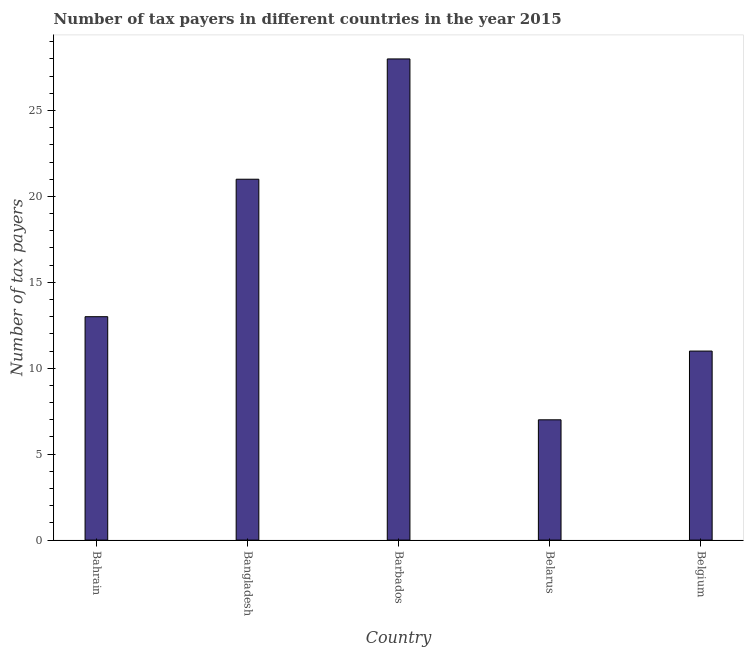Does the graph contain any zero values?
Your response must be concise. No. What is the title of the graph?
Your answer should be compact. Number of tax payers in different countries in the year 2015. What is the label or title of the Y-axis?
Your response must be concise. Number of tax payers. Across all countries, what is the minimum number of tax payers?
Provide a succinct answer. 7. In which country was the number of tax payers maximum?
Your answer should be very brief. Barbados. In which country was the number of tax payers minimum?
Give a very brief answer. Belarus. What is the median number of tax payers?
Your answer should be compact. 13. In how many countries, is the number of tax payers greater than 21 ?
Give a very brief answer. 1. What is the ratio of the number of tax payers in Bangladesh to that in Belgium?
Ensure brevity in your answer.  1.91. Is the number of tax payers in Bangladesh less than that in Belgium?
Make the answer very short. No. Is the difference between the number of tax payers in Bahrain and Barbados greater than the difference between any two countries?
Offer a very short reply. No. What is the difference between the highest and the second highest number of tax payers?
Your answer should be compact. 7. Is the sum of the number of tax payers in Bahrain and Bangladesh greater than the maximum number of tax payers across all countries?
Make the answer very short. Yes. What is the difference between the highest and the lowest number of tax payers?
Make the answer very short. 21. In how many countries, is the number of tax payers greater than the average number of tax payers taken over all countries?
Your answer should be compact. 2. How many bars are there?
Your response must be concise. 5. How many countries are there in the graph?
Your answer should be compact. 5. Are the values on the major ticks of Y-axis written in scientific E-notation?
Provide a short and direct response. No. What is the Number of tax payers of Bangladesh?
Make the answer very short. 21. What is the difference between the Number of tax payers in Bahrain and Bangladesh?
Ensure brevity in your answer.  -8. What is the difference between the Number of tax payers in Bahrain and Belgium?
Provide a short and direct response. 2. What is the difference between the Number of tax payers in Bangladesh and Barbados?
Offer a terse response. -7. What is the difference between the Number of tax payers in Bangladesh and Belarus?
Make the answer very short. 14. What is the difference between the Number of tax payers in Bangladesh and Belgium?
Your answer should be very brief. 10. What is the difference between the Number of tax payers in Barbados and Belarus?
Make the answer very short. 21. What is the difference between the Number of tax payers in Barbados and Belgium?
Provide a short and direct response. 17. What is the ratio of the Number of tax payers in Bahrain to that in Bangladesh?
Offer a terse response. 0.62. What is the ratio of the Number of tax payers in Bahrain to that in Barbados?
Offer a very short reply. 0.46. What is the ratio of the Number of tax payers in Bahrain to that in Belarus?
Make the answer very short. 1.86. What is the ratio of the Number of tax payers in Bahrain to that in Belgium?
Offer a very short reply. 1.18. What is the ratio of the Number of tax payers in Bangladesh to that in Belgium?
Offer a very short reply. 1.91. What is the ratio of the Number of tax payers in Barbados to that in Belgium?
Your answer should be very brief. 2.54. What is the ratio of the Number of tax payers in Belarus to that in Belgium?
Offer a terse response. 0.64. 